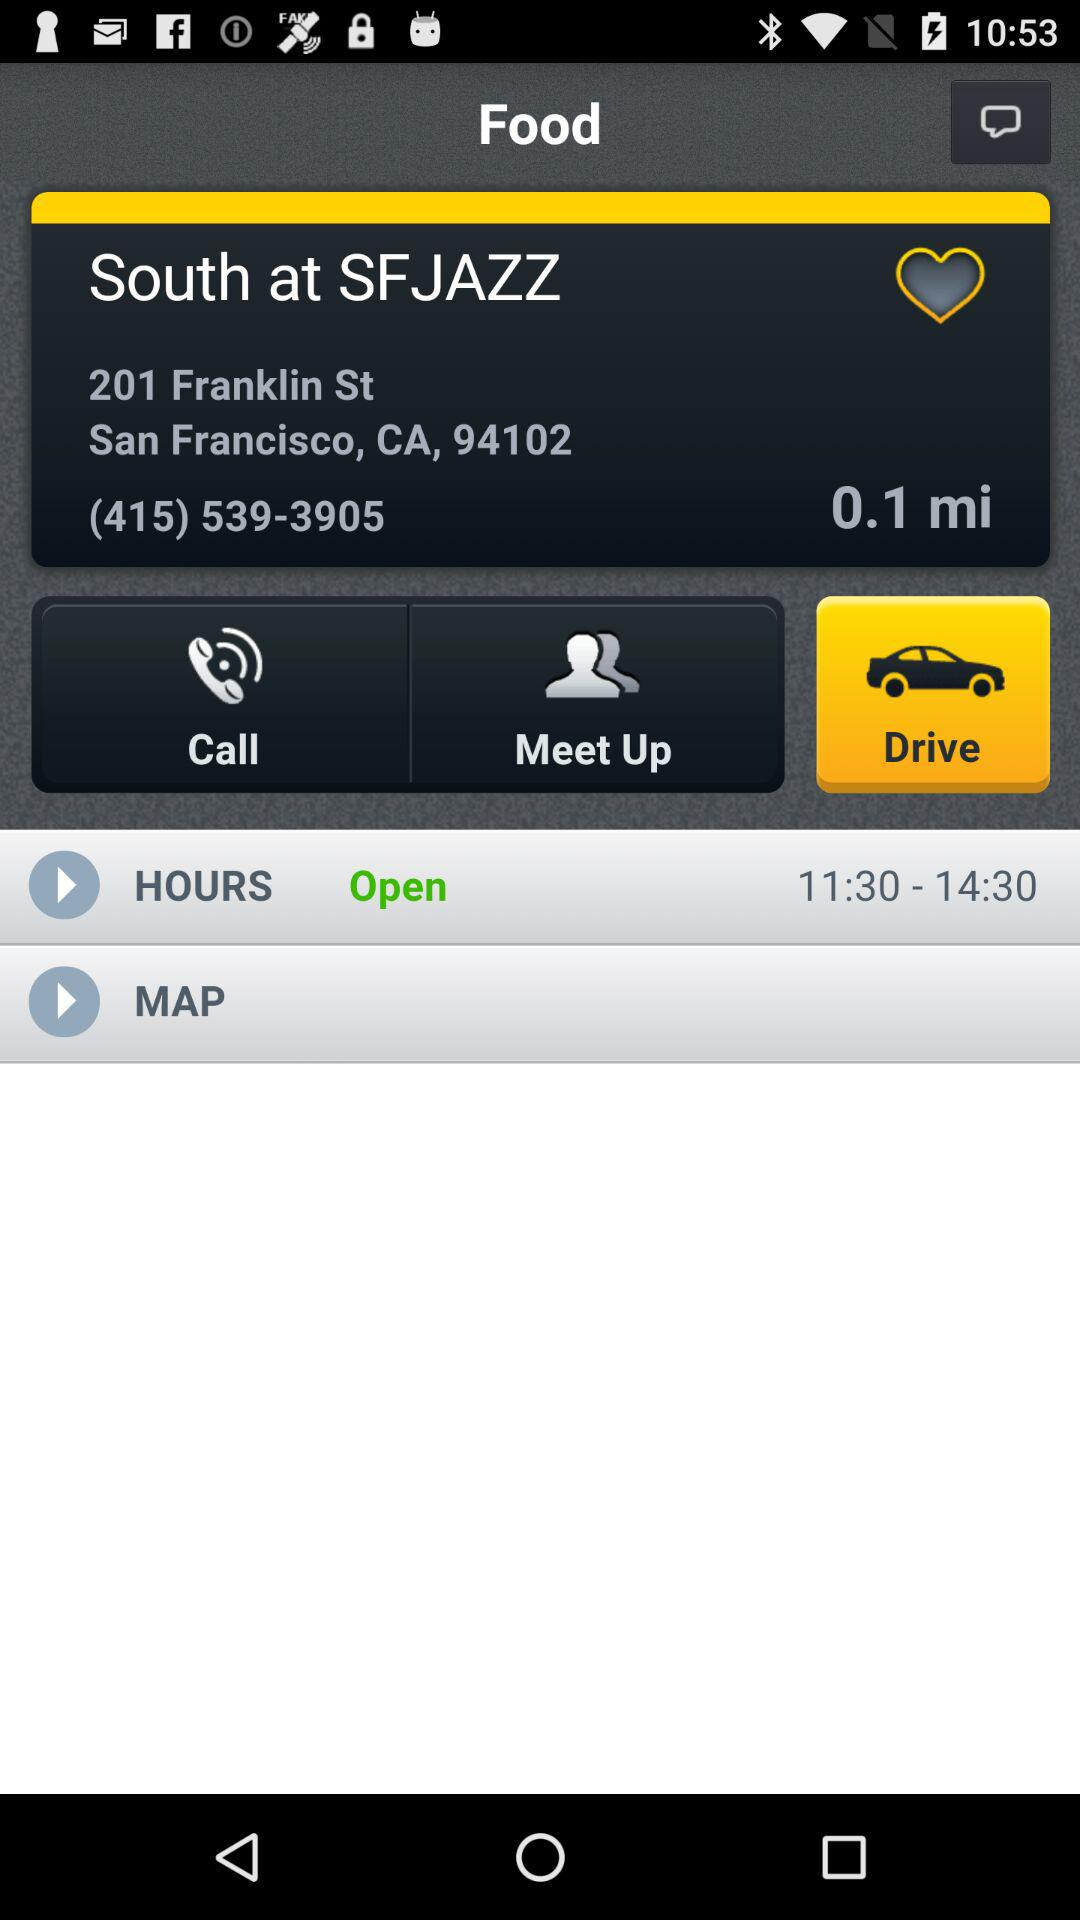What is the distance? The distance is 0.1 miles. 